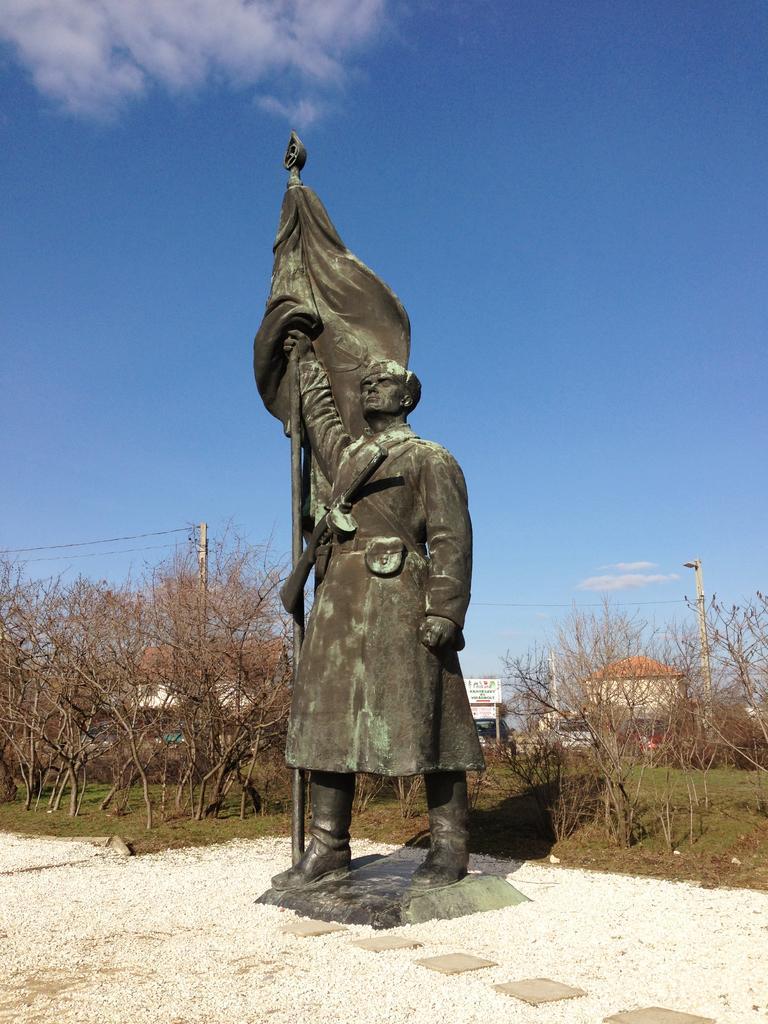Can you describe this image briefly? In this image we can see a statue of a person placed on the ground. In the background, we can see buildings, trees, some poles and the sky. 